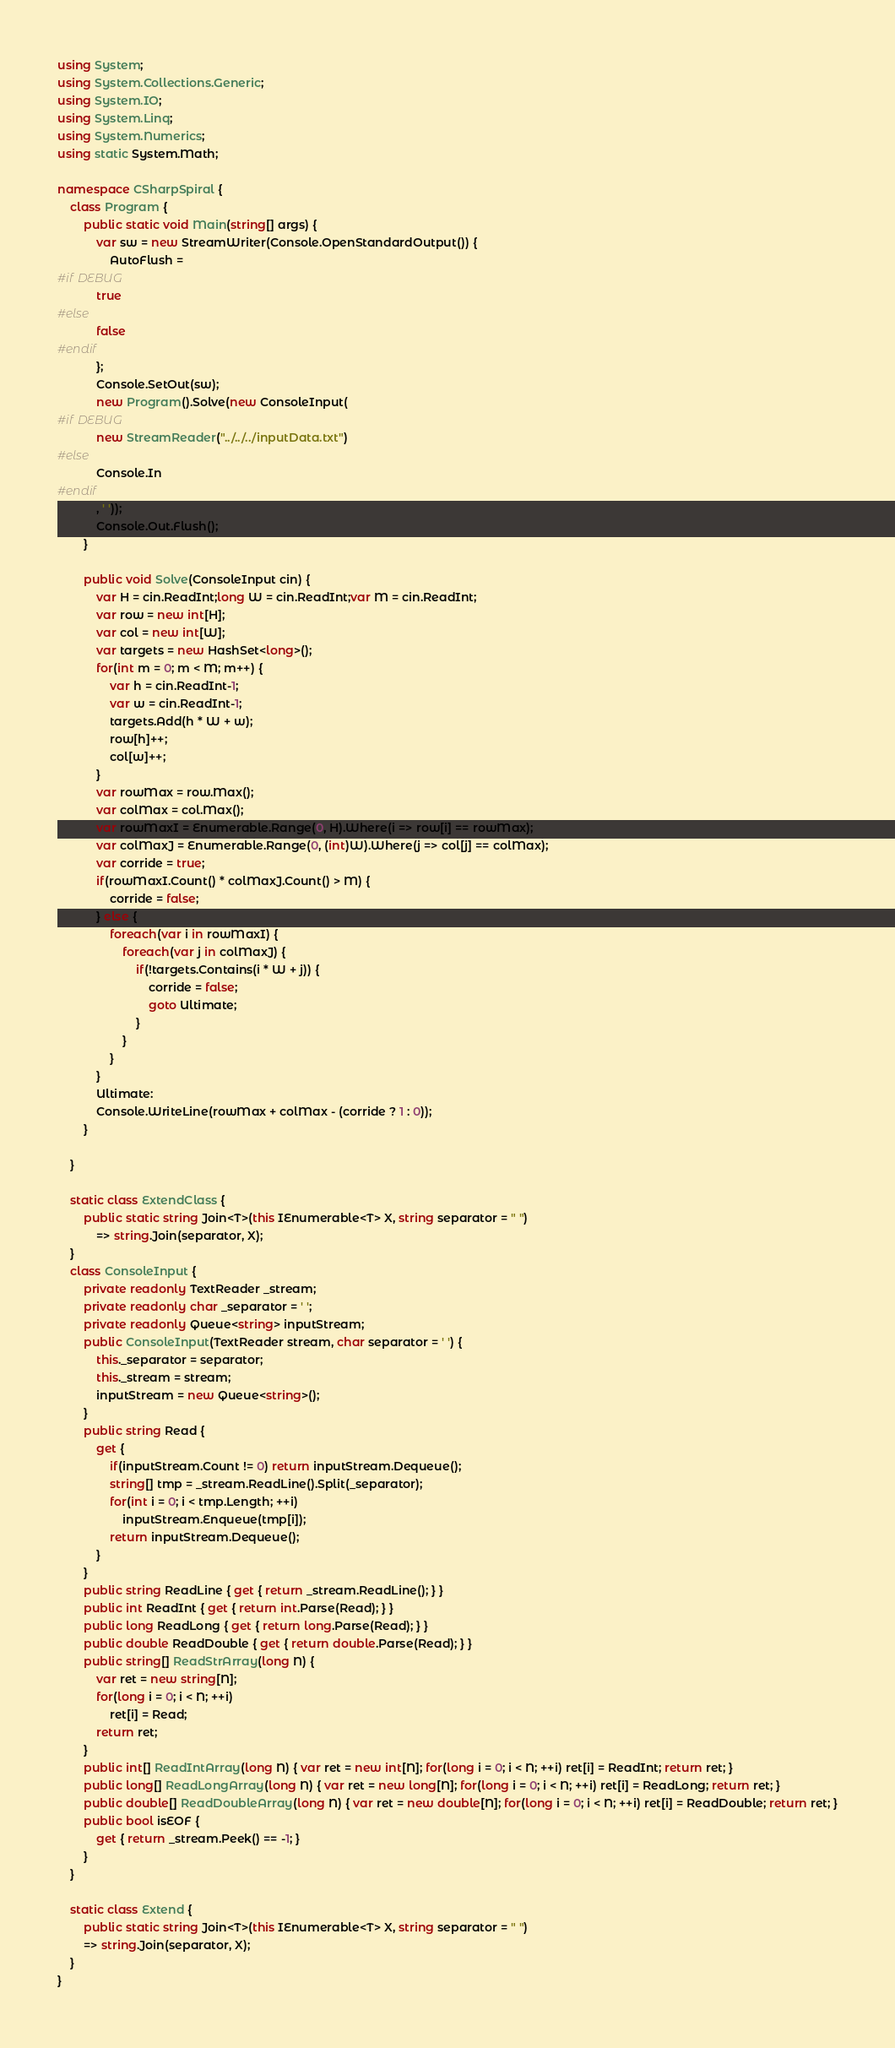Convert code to text. <code><loc_0><loc_0><loc_500><loc_500><_C#_>using System;
using System.Collections.Generic;
using System.IO;
using System.Linq;
using System.Numerics;
using static System.Math;

namespace CSharpSpiral {
	class Program {
		public static void Main(string[] args) {
			var sw = new StreamWriter(Console.OpenStandardOutput()) {
				AutoFlush =
#if DEBUG
			true
#else
			false
#endif
			};
			Console.SetOut(sw);
			new Program().Solve(new ConsoleInput(
#if DEBUG
			new StreamReader("../../../inputData.txt")
#else
			Console.In
#endif
			, ' '));
			Console.Out.Flush();
		}

		public void Solve(ConsoleInput cin) {
			var H = cin.ReadInt;long W = cin.ReadInt;var M = cin.ReadInt;
			var row = new int[H];
			var col = new int[W];
			var targets = new HashSet<long>();
			for(int m = 0; m < M; m++) {
				var h = cin.ReadInt-1;
				var w = cin.ReadInt-1;
				targets.Add(h * W + w);
				row[h]++;
				col[w]++;
			}
			var rowMax = row.Max();
			var colMax = col.Max();
			var rowMaxI = Enumerable.Range(0, H).Where(i => row[i] == rowMax);
			var colMaxJ = Enumerable.Range(0, (int)W).Where(j => col[j] == colMax);
			var corride = true;
			if(rowMaxI.Count() * colMaxJ.Count() > M) {
				corride = false;
			} else {
				foreach(var i in rowMaxI) {
					foreach(var j in colMaxJ) {
						if(!targets.Contains(i * W + j)) {
							corride = false;
							goto Ultimate;
						}
					}
				}
			}
			Ultimate:
			Console.WriteLine(rowMax + colMax - (corride ? 1 : 0));
		}

	}

	static class ExtendClass {
		public static string Join<T>(this IEnumerable<T> X, string separator = " ")
			=> string.Join(separator, X);
	}
	class ConsoleInput {
		private readonly TextReader _stream;
		private readonly char _separator = ' ';
		private readonly Queue<string> inputStream;
		public ConsoleInput(TextReader stream, char separator = ' ') {
			this._separator = separator;
			this._stream = stream;
			inputStream = new Queue<string>();
		}
		public string Read {
			get {
				if(inputStream.Count != 0) return inputStream.Dequeue();
				string[] tmp = _stream.ReadLine().Split(_separator);
				for(int i = 0; i < tmp.Length; ++i)
					inputStream.Enqueue(tmp[i]);
				return inputStream.Dequeue();
			}
		}
		public string ReadLine { get { return _stream.ReadLine(); } }
		public int ReadInt { get { return int.Parse(Read); } }
		public long ReadLong { get { return long.Parse(Read); } }
		public double ReadDouble { get { return double.Parse(Read); } }
		public string[] ReadStrArray(long N) {
			var ret = new string[N];
			for(long i = 0; i < N; ++i)
				ret[i] = Read;
			return ret;
		}
		public int[] ReadIntArray(long N) { var ret = new int[N]; for(long i = 0; i < N; ++i) ret[i] = ReadInt; return ret; }
		public long[] ReadLongArray(long N) { var ret = new long[N]; for(long i = 0; i < N; ++i) ret[i] = ReadLong; return ret; }
		public double[] ReadDoubleArray(long N) { var ret = new double[N]; for(long i = 0; i < N; ++i) ret[i] = ReadDouble; return ret; }
		public bool isEOF {
			get { return _stream.Peek() == -1; }
		}
	}

	static class Extend {
		public static string Join<T>(this IEnumerable<T> X, string separator = " ")
		=> string.Join(separator, X);
	}
}
</code> 